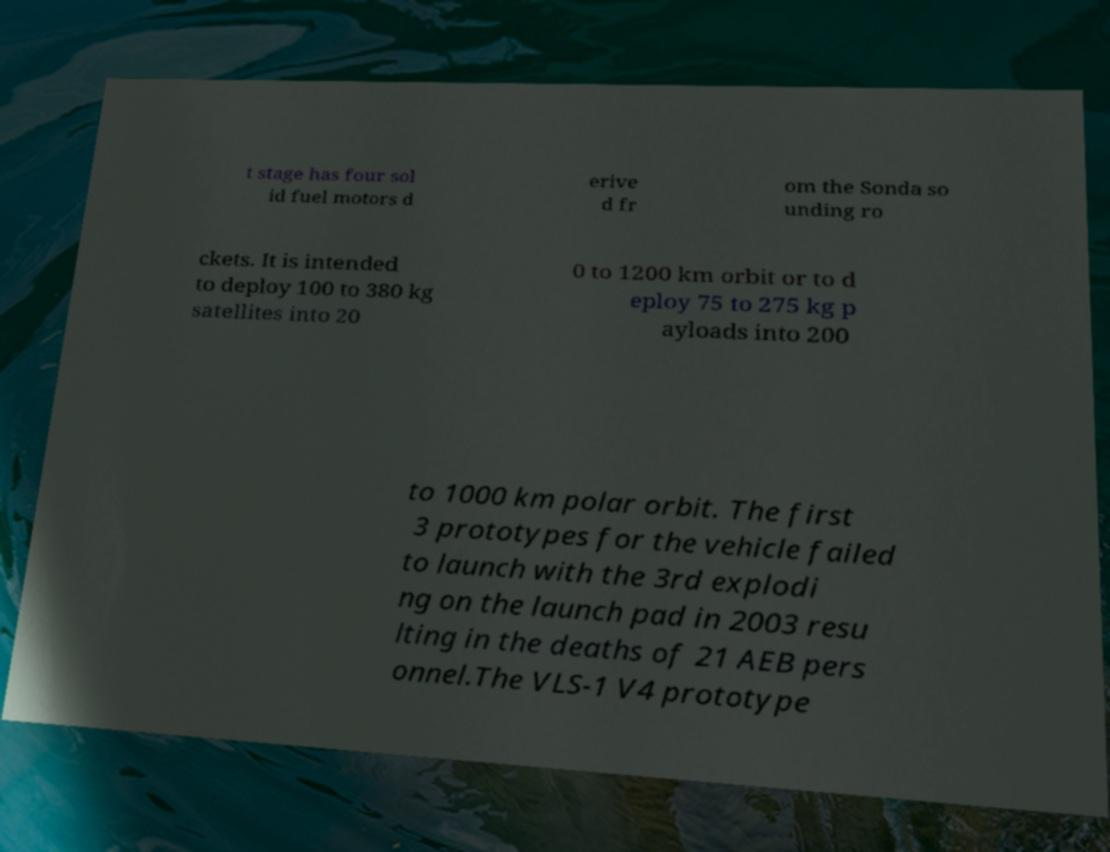Could you extract and type out the text from this image? t stage has four sol id fuel motors d erive d fr om the Sonda so unding ro ckets. It is intended to deploy 100 to 380 kg satellites into 20 0 to 1200 km orbit or to d eploy 75 to 275 kg p ayloads into 200 to 1000 km polar orbit. The first 3 prototypes for the vehicle failed to launch with the 3rd explodi ng on the launch pad in 2003 resu lting in the deaths of 21 AEB pers onnel.The VLS-1 V4 prototype 